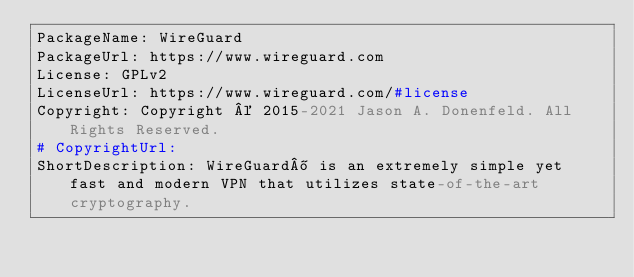Convert code to text. <code><loc_0><loc_0><loc_500><loc_500><_YAML_>PackageName: WireGuard
PackageUrl: https://www.wireguard.com
License: GPLv2
LicenseUrl: https://www.wireguard.com/#license
Copyright: Copyright © 2015-2021 Jason A. Donenfeld. All Rights Reserved.
# CopyrightUrl: 
ShortDescription: WireGuard® is an extremely simple yet fast and modern VPN that utilizes state-of-the-art cryptography.</code> 